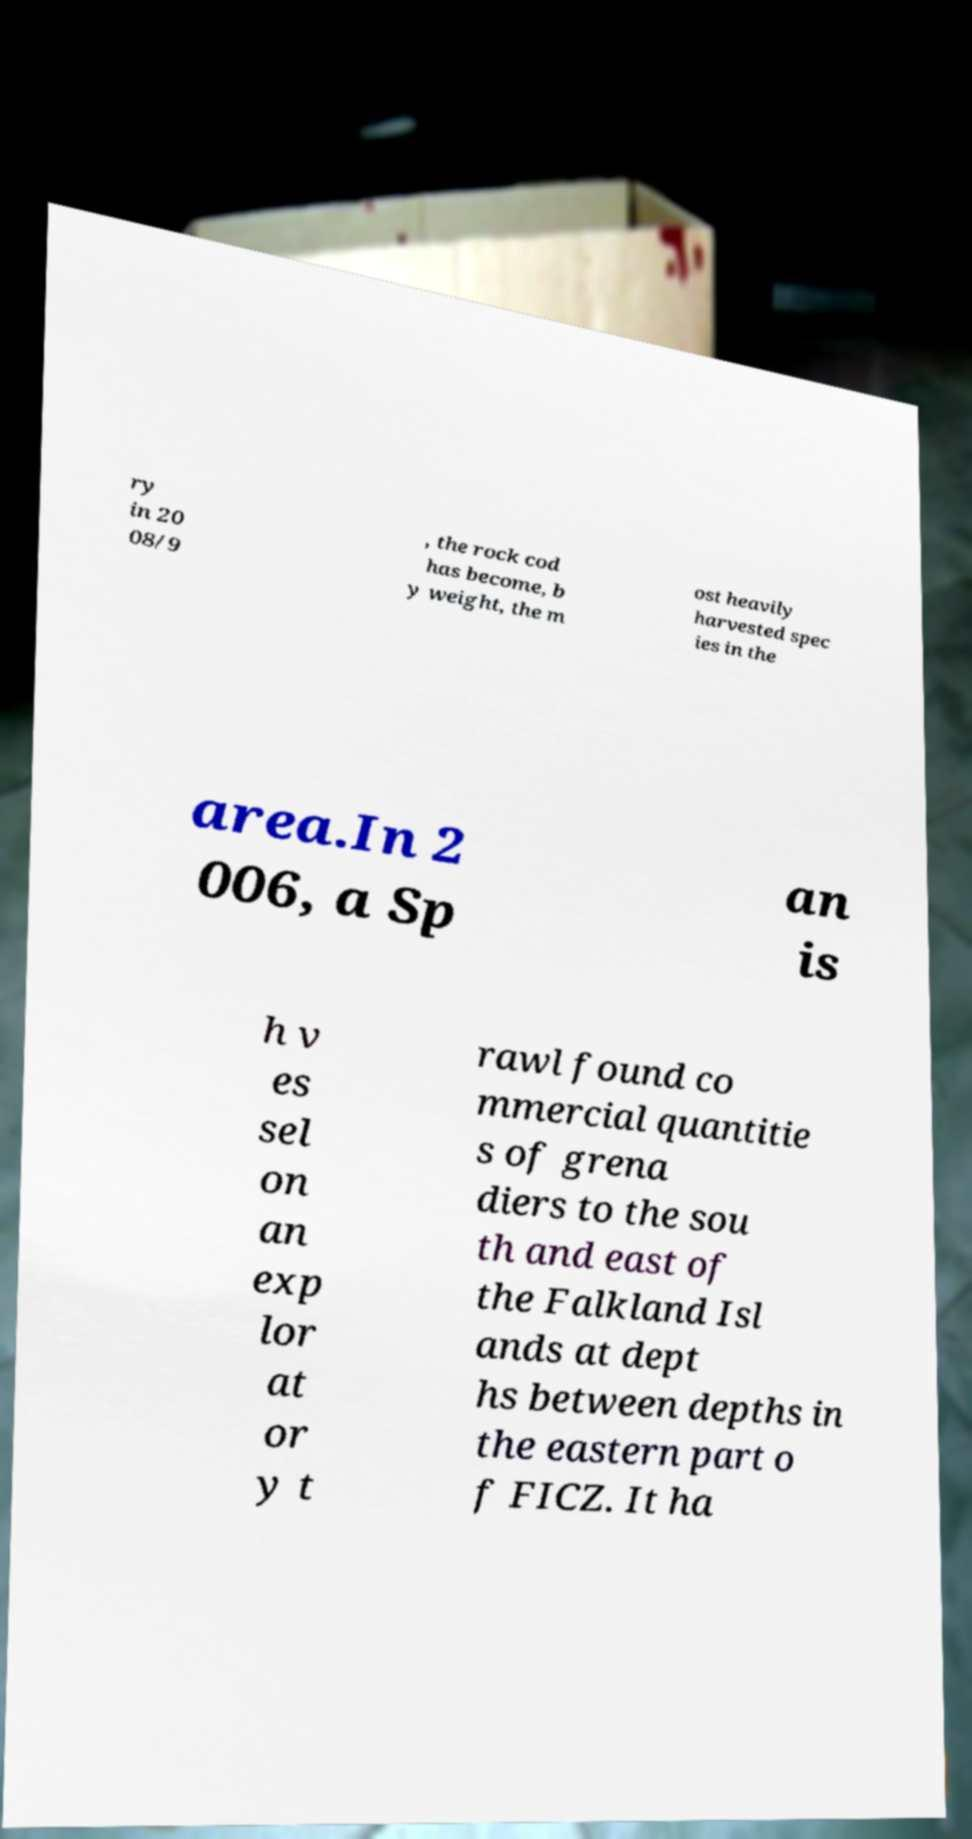Please read and relay the text visible in this image. What does it say? ry in 20 08/9 , the rock cod has become, b y weight, the m ost heavily harvested spec ies in the area.In 2 006, a Sp an is h v es sel on an exp lor at or y t rawl found co mmercial quantitie s of grena diers to the sou th and east of the Falkland Isl ands at dept hs between depths in the eastern part o f FICZ. It ha 